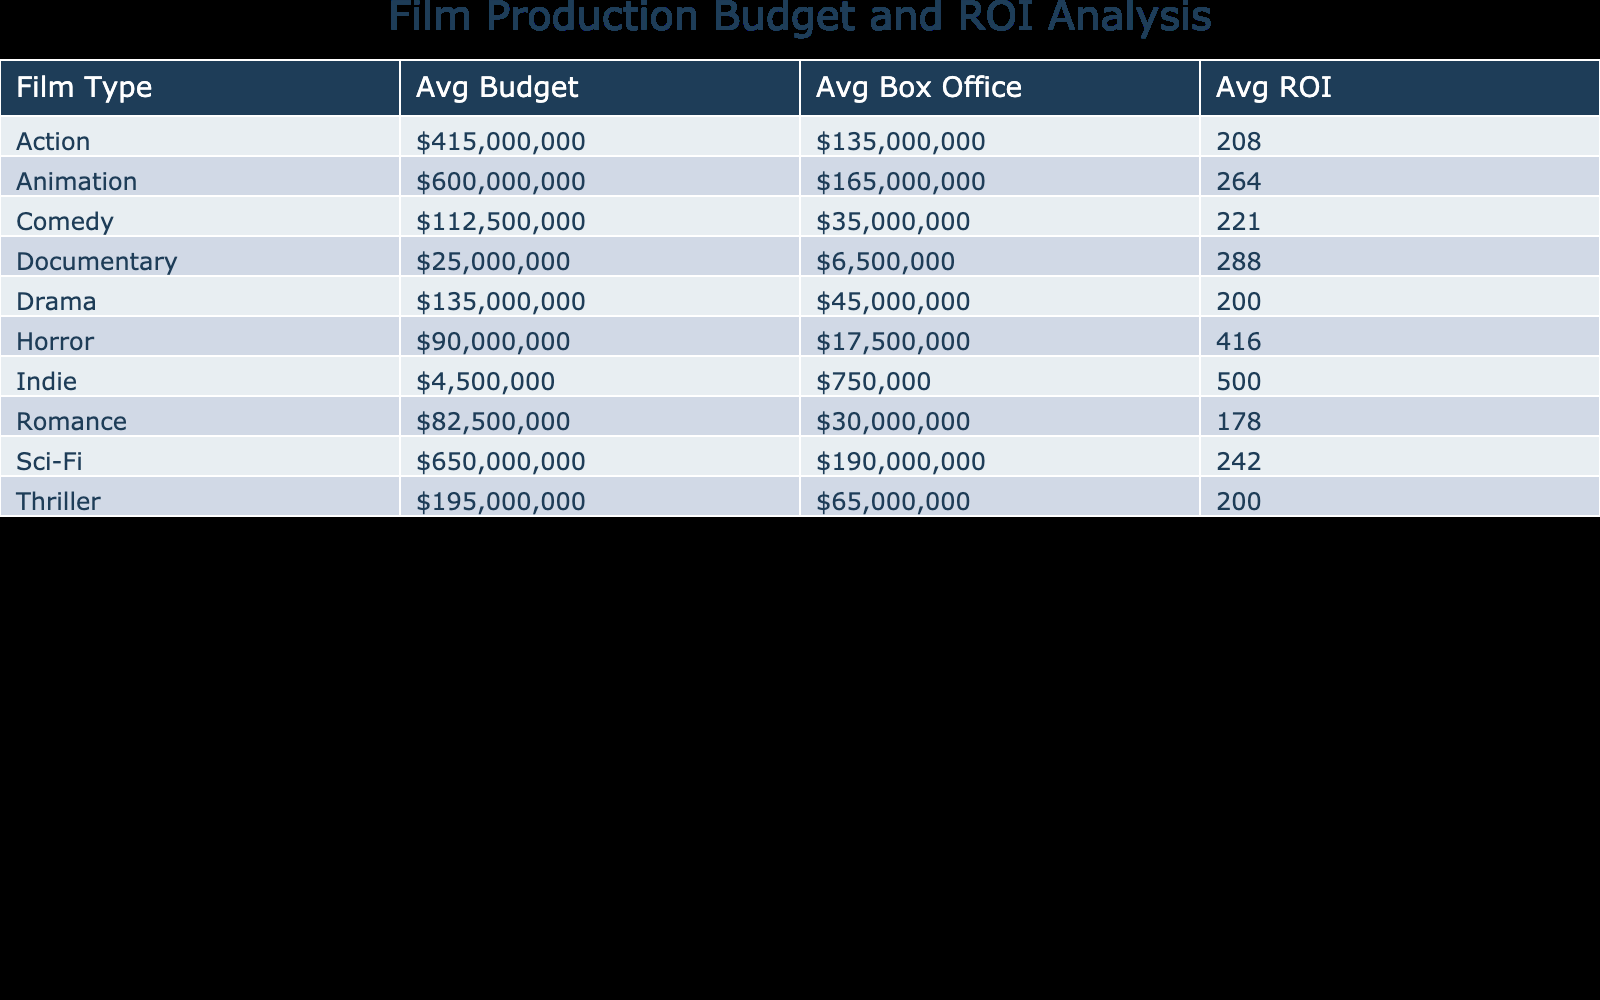What is the average budget for Action films? To find the average budget for Action films, I look at the "Avg Budget" column in the table under Action. The average budget for Action films is 135 million USD (calculated by averaging the budgets of the two Action films: (150000000 + 120000000) / 2).
Answer: 135000000 Which film type has the highest average ROI? By examining the "Avg ROI" column, I see that the Indie genre has the highest average ROI at 500 percent. This is confirmed by checking the value listed in that row.
Answer: 500 Is the average box office revenue for Horror films greater than 70 million USD? I check the "Avg Box Office" for Horror films, which is 90 million USD. Therefore, the statement is true as it exceeds 70 million.
Answer: Yes What is the difference in average box office revenue between Sci-Fi and Comedy films? I find the "Avg Box Office" for Sci-Fi films is 650 million USD and for Comedy films it is 115 million USD. The difference is 650 million - 115 million = 535 million USD.
Answer: 535000000 Which production company produced the film with the highest average box office revenue? I examine the "Avg Box Office" column, and the highest value is from the Animation category at 600 million USD, produced by Walt Disney Animation Studios.
Answer: Walt Disney Animation Studios How many film types have an average ROI greater than 250 percent? I review the "Avg ROI" column and see that Horror (433), Indie (500), and Documentary (275) meet the criteria, totaling three film types with an average ROI above 250 percent.
Answer: 3 Is there a film type with an average budget less than 10 million USD? By checking the "Avg Budget" column, the lowest average budget appears to be for the Indie films at 0.75 million USD, which confirms that there is indeed a film type below 10 million.
Answer: Yes What is the average ROI for Romance films? Looking at the "Avg ROI" for Romance films in the table, I find it is 178.5 percent, resulting from averaging the values from both Romance entries: (200 + 157) / 2.
Answer: 178.5 For which film type is the average budget closest to 50 million USD? I compare the average budgets across several film types and see that Drama films average 45 million USD, making it the closest to 50 million.
Answer: Drama 